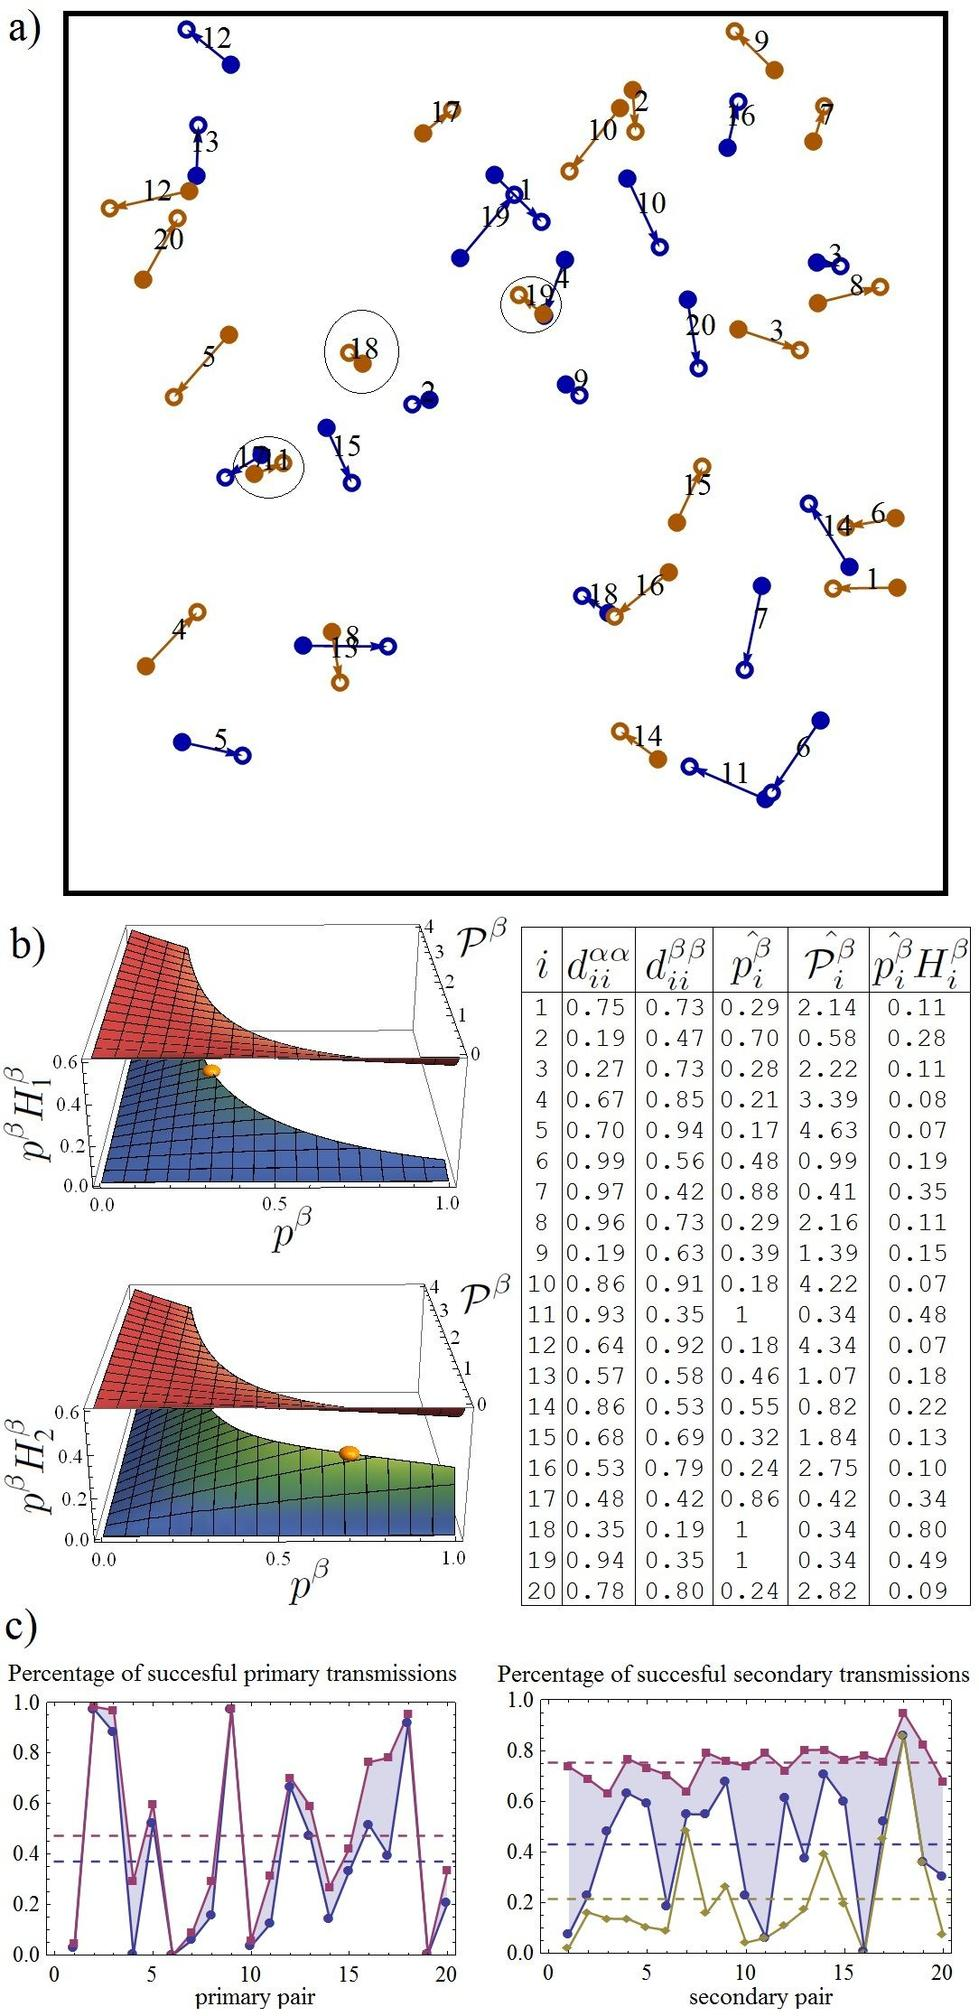What does the color difference between nodes like Q18 and Q10 imply about their relationships or functions? In network visualizations such as the one shown, color differences often emphasize different types of roles, states, or activities of the nodes. For instance, Q18's color may indicate that it is currently more active, stressed, or critical in the network's functionality compared to Q10, which might be at a more neutral or less active state. This distinction can be essential for identifying key nodes that might have higher importance or different responsibilities in the network's overall behavior. 